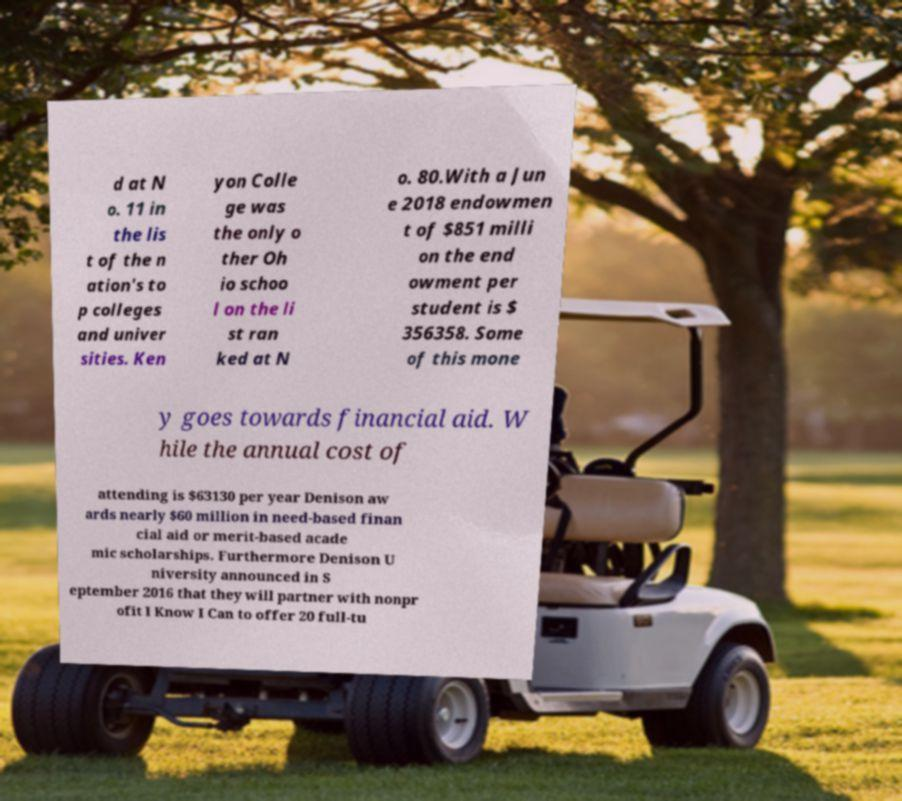Please identify and transcribe the text found in this image. d at N o. 11 in the lis t of the n ation's to p colleges and univer sities. Ken yon Colle ge was the only o ther Oh io schoo l on the li st ran ked at N o. 80.With a Jun e 2018 endowmen t of $851 milli on the end owment per student is $ 356358. Some of this mone y goes towards financial aid. W hile the annual cost of attending is $63130 per year Denison aw ards nearly $60 million in need-based finan cial aid or merit-based acade mic scholarships. Furthermore Denison U niversity announced in S eptember 2016 that they will partner with nonpr ofit I Know I Can to offer 20 full-tu 